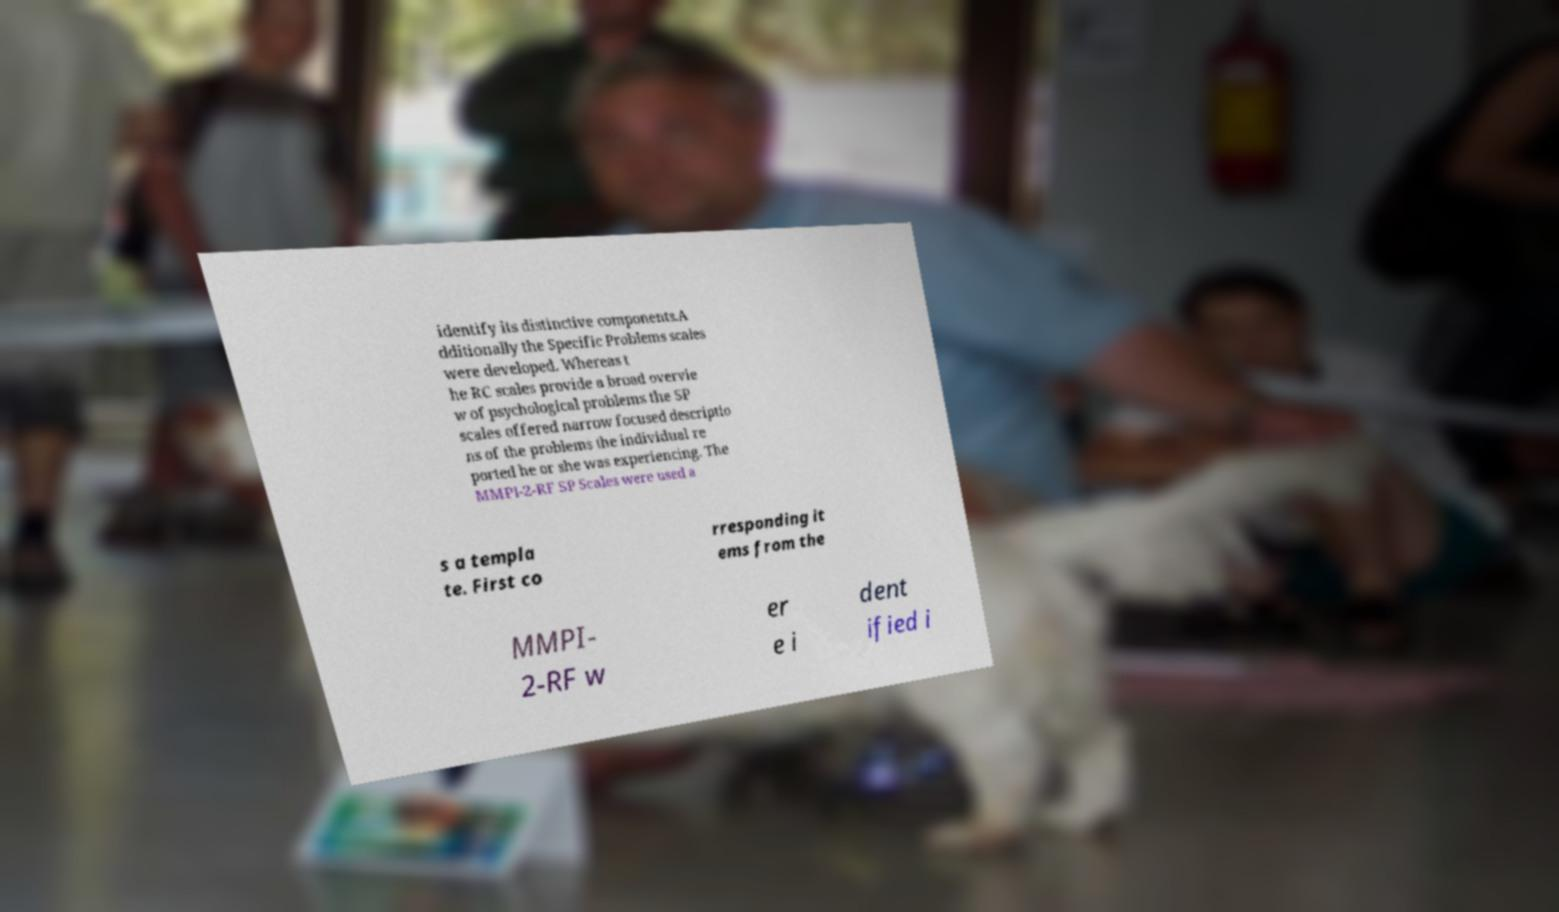Could you extract and type out the text from this image? identify its distinctive components.A dditionally the Specific Problems scales were developed. Whereas t he RC scales provide a broad overvie w of psychological problems the SP scales offered narrow focused descriptio ns of the problems the individual re ported he or she was experiencing. The MMPI-2-RF SP Scales were used a s a templa te. First co rresponding it ems from the MMPI- 2-RF w er e i dent ified i 